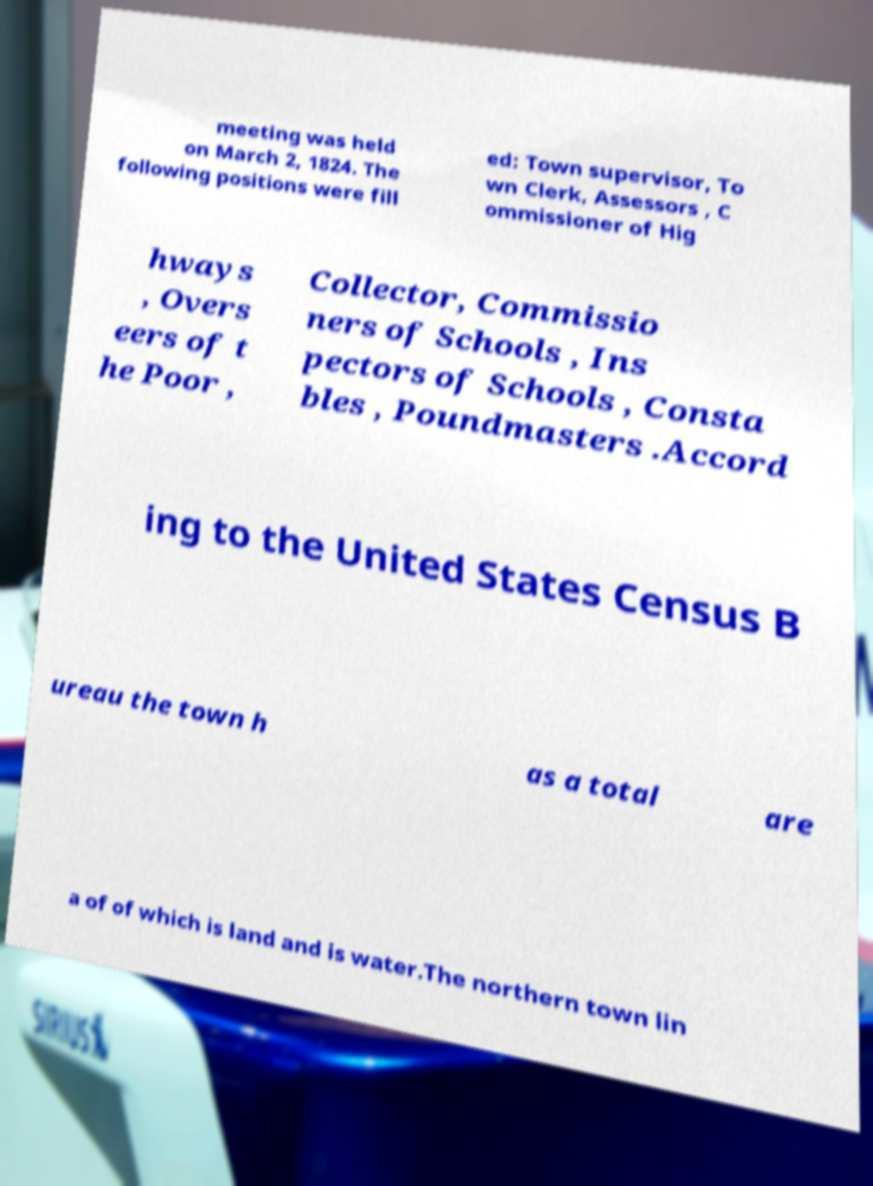Can you accurately transcribe the text from the provided image for me? meeting was held on March 2, 1824. The following positions were fill ed: Town supervisor, To wn Clerk, Assessors , C ommissioner of Hig hways , Overs eers of t he Poor , Collector, Commissio ners of Schools , Ins pectors of Schools , Consta bles , Poundmasters .Accord ing to the United States Census B ureau the town h as a total are a of of which is land and is water.The northern town lin 